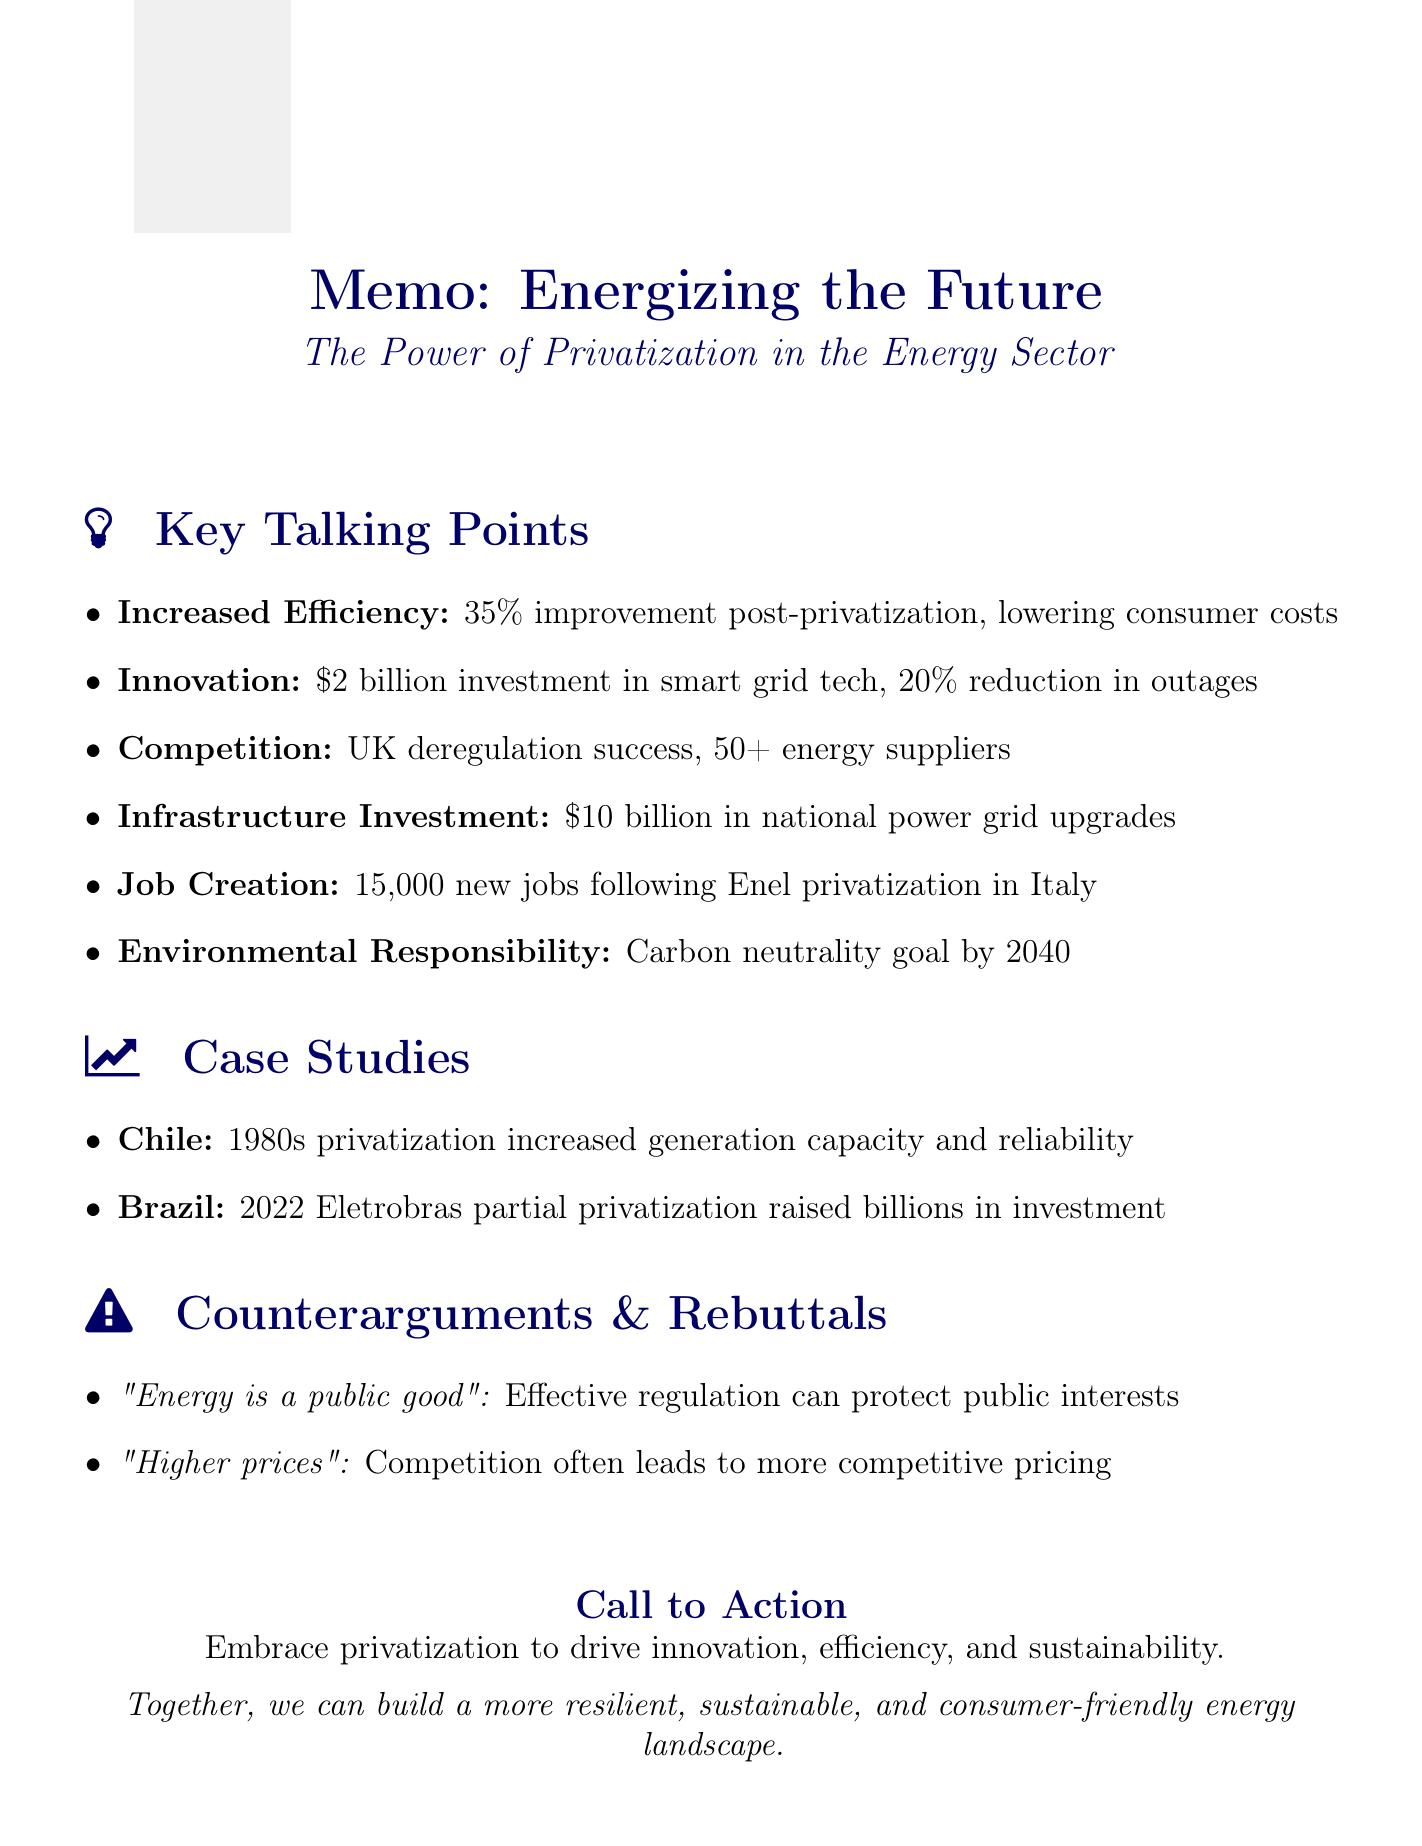What is the title of the speech? The title of the speech is clearly stated in the document under the heading "speech_title."
Answer: Energizing the Future: The Power of Privatization in the Energy Sector How much improvement in operational efficiency did GlobalEnergy Corp. achieve? The improvement in operational efficiency is specified in the key talking points section of the document.
Answer: 35% What major investment did GlobalEnergy Corp. make in smart grid technology? The document provides a specific monetary amount for the investment made by GlobalEnergy Corp.
Answer: $2 billion How many new jobs were created in Italy's energy sector following the privatization of Enel? The number of new jobs created as mentioned in the talking points section is specified.
Answer: 15,000 Which country's energy market deregulation resulted in over 50 energy suppliers? The reference to energy market deregulation is found in the talking points related to competition.
Answer: UK What is the call to action in the closing remarks? The call to action is highlighted in the closing remarks section, urging industry leaders.
Answer: Embrace privatization to drive innovation, efficiency, and sustainability What environmental goal has GlobalEnergy Corp. committed to achieving by 2040? The environmental responsibility section mentions this specific commitment.
Answer: Carbon neutrality Which two case studies are cited in the document? The case studies section lists specific countries that are examples of successful privatization.
Answer: Chile and Brazil 